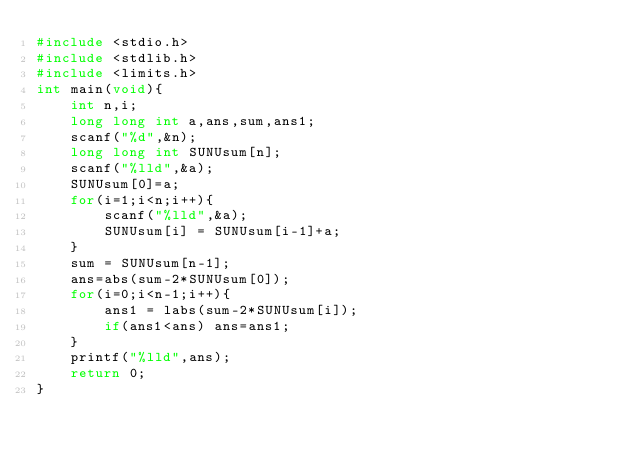Convert code to text. <code><loc_0><loc_0><loc_500><loc_500><_C_>#include <stdio.h>
#include <stdlib.h>
#include <limits.h>
int main(void){
	int n,i;
	long long int a,ans,sum,ans1;
	scanf("%d",&n);
	long long int SUNUsum[n];
	scanf("%lld",&a);
	SUNUsum[0]=a;
	for(i=1;i<n;i++){
		scanf("%lld",&a);
		SUNUsum[i] = SUNUsum[i-1]+a;
	}
	sum = SUNUsum[n-1];
	ans=abs(sum-2*SUNUsum[0]);
	for(i=0;i<n-1;i++){
		ans1 = labs(sum-2*SUNUsum[i]);
		if(ans1<ans) ans=ans1;
	}
	printf("%lld",ans);
	return 0;
}</code> 